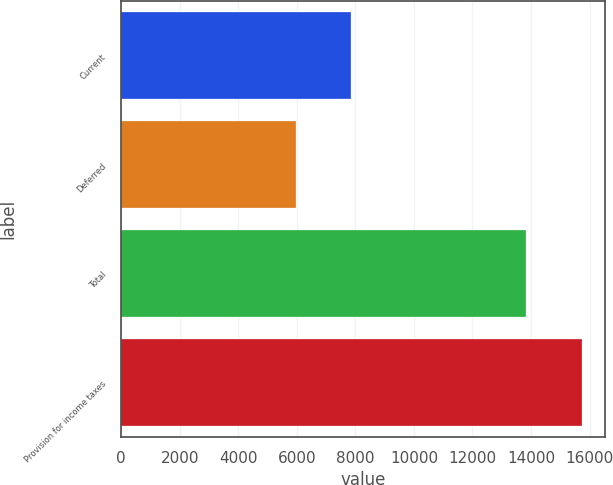Convert chart to OTSL. <chart><loc_0><loc_0><loc_500><loc_500><bar_chart><fcel>Current<fcel>Deferred<fcel>Total<fcel>Provision for income taxes<nl><fcel>7842<fcel>5980<fcel>13822<fcel>15738<nl></chart> 